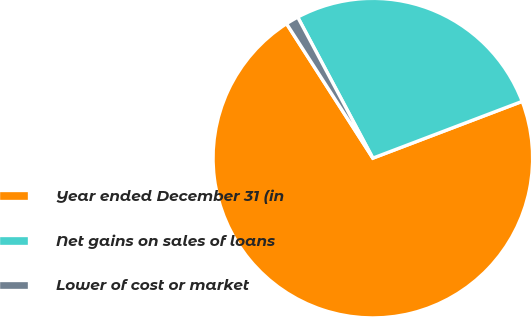<chart> <loc_0><loc_0><loc_500><loc_500><pie_chart><fcel>Year ended December 31 (in<fcel>Net gains on sales of loans<fcel>Lower of cost or market<nl><fcel>71.7%<fcel>27.01%<fcel>1.29%<nl></chart> 